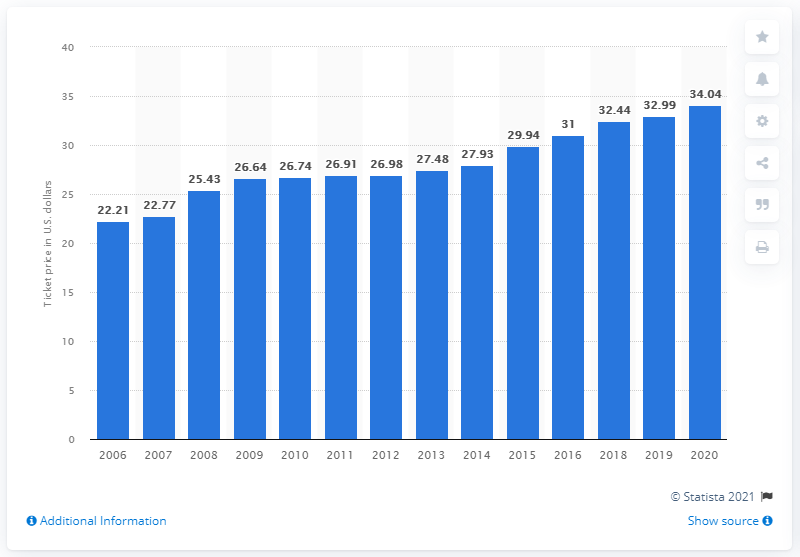Give some essential details in this illustration. The average ticket price in 2020 was 34.04 dollars. 